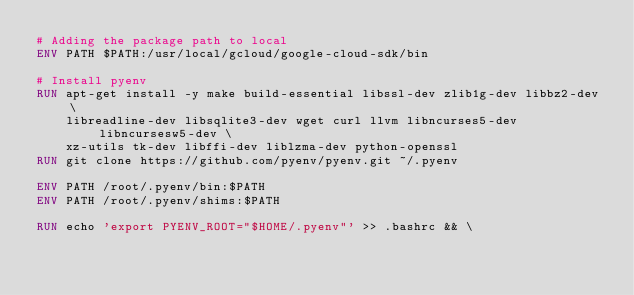Convert code to text. <code><loc_0><loc_0><loc_500><loc_500><_Dockerfile_># Adding the package path to local
ENV PATH $PATH:/usr/local/gcloud/google-cloud-sdk/bin

# Install pyenv
RUN apt-get install -y make build-essential libssl-dev zlib1g-dev libbz2-dev \
    libreadline-dev libsqlite3-dev wget curl llvm libncurses5-dev libncursesw5-dev \
    xz-utils tk-dev libffi-dev liblzma-dev python-openssl
RUN git clone https://github.com/pyenv/pyenv.git ~/.pyenv

ENV PATH /root/.pyenv/bin:$PATH
ENV PATH /root/.pyenv/shims:$PATH

RUN echo 'export PYENV_ROOT="$HOME/.pyenv"' >> .bashrc && \</code> 